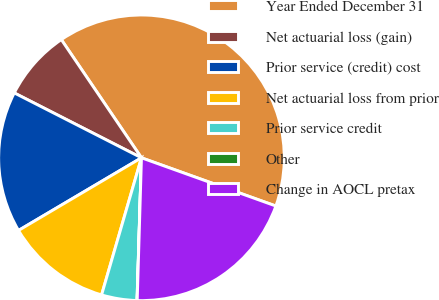Convert chart. <chart><loc_0><loc_0><loc_500><loc_500><pie_chart><fcel>Year Ended December 31<fcel>Net actuarial loss (gain)<fcel>Prior service (credit) cost<fcel>Net actuarial loss from prior<fcel>Prior service credit<fcel>Other<fcel>Change in AOCL pretax<nl><fcel>39.96%<fcel>8.01%<fcel>16.0%<fcel>12.0%<fcel>4.01%<fcel>0.02%<fcel>19.99%<nl></chart> 